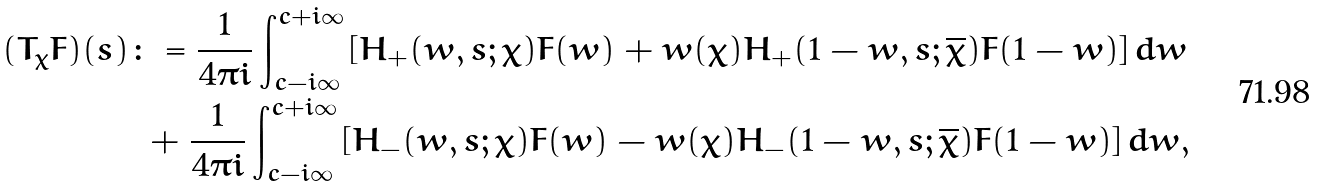Convert formula to latex. <formula><loc_0><loc_0><loc_500><loc_500>( T _ { \chi } F ) ( s ) & \colon = \frac { 1 } { 4 \pi i } \int _ { c - i \infty } ^ { c + i \infty } \left [ H _ { + } ( w , s ; \chi ) F ( w ) + w ( \chi ) H _ { + } ( 1 - w , s ; \overline { \chi } ) F ( 1 - w ) \right ] d w \\ & \ + \frac { 1 } { 4 \pi i } \int _ { c - i \infty } ^ { c + i \infty } \left [ H _ { - } ( w , s ; \chi ) F ( w ) - w ( \chi ) H _ { - } ( 1 - w , s ; \overline { \chi } ) F ( 1 - w ) \right ] d w ,</formula> 